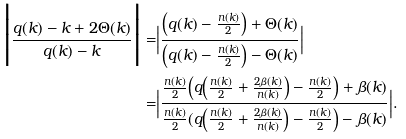Convert formula to latex. <formula><loc_0><loc_0><loc_500><loc_500>\Big | \frac { q ( k ) - k + 2 \Theta ( k ) } { q ( k ) - k } \Big | = & \Big | \frac { \Big ( q ( k ) - \frac { n ( k ) } { 2 } \Big ) + \Theta ( k ) } { \Big ( q ( k ) - \frac { n ( k ) } { 2 } \Big ) - \Theta ( k ) } \Big | \\ = & \Big | \frac { \frac { n ( k ) } { 2 } \Big ( q \Big ( \frac { n ( k ) } { 2 } + \frac { 2 \beta ( k ) } { n ( k ) } \Big ) - \frac { n ( k ) } { 2 } \Big ) + \beta ( k ) } { \frac { n ( k ) } { 2 } ( q \Big ( \frac { n ( k ) } { 2 } + \frac { 2 \beta ( k ) } { n ( k ) } \Big ) - \frac { n ( k ) } { 2 } \Big ) - \beta ( k ) } \Big | .</formula> 